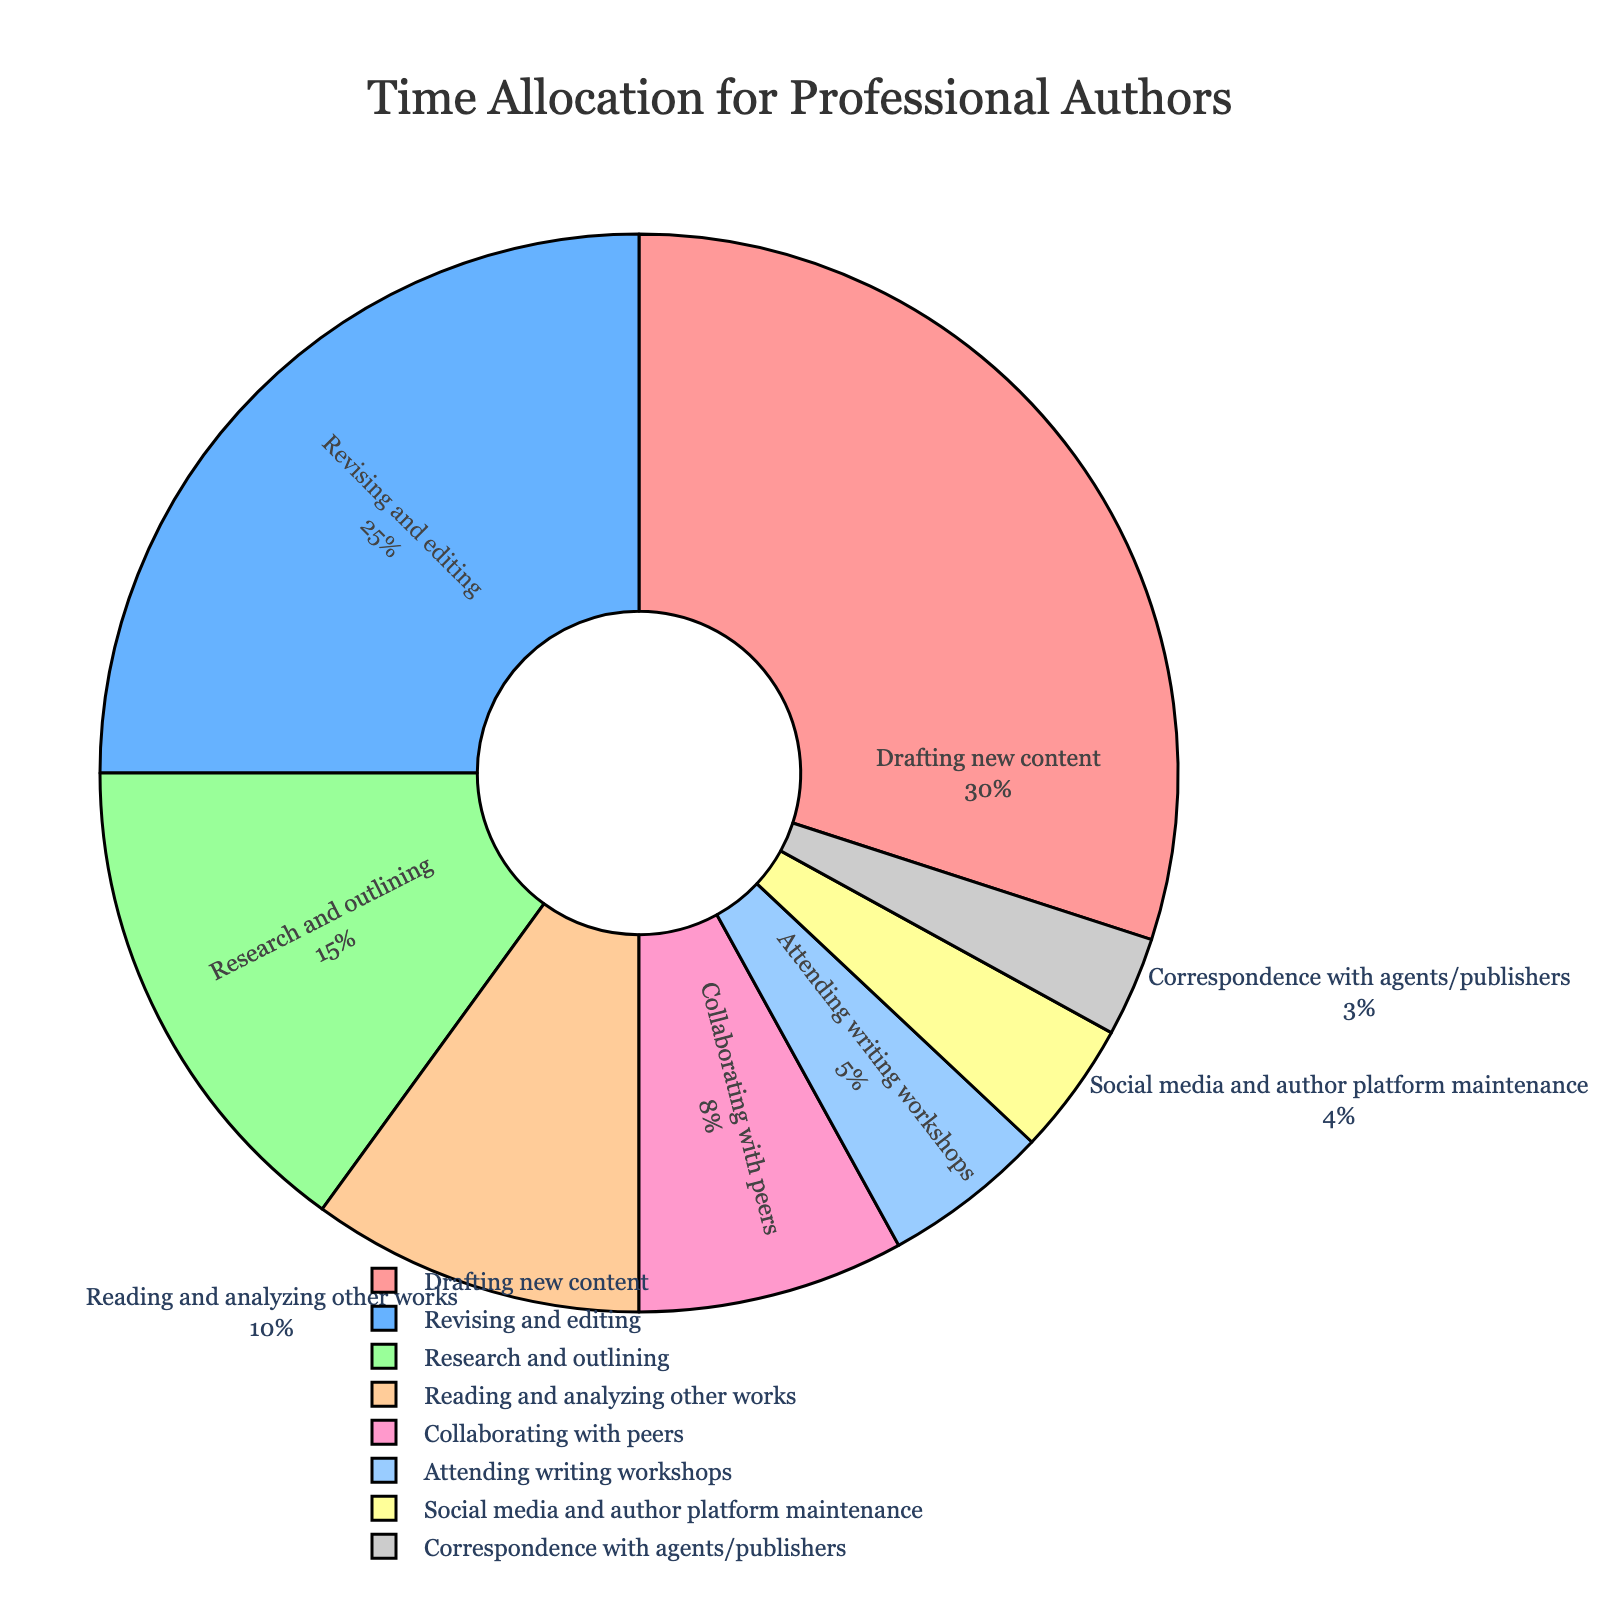Which activity do professional authors spend the most time on? The chart shows multiple activities with different percentages. By observing the chart, the activity with the largest slice is easily identified as the one with 30%.
Answer: Drafting new content What is the combined percentage of time spent on research and outlining and reading and analyzing other works? To find the combined percentage, add the percentages of time spent on research and outlining (15%) and reading and analyzing other works (10%). 15% + 10% = 25%.
Answer: 25% How much more time do professional authors spend on revising and editing compared to attending writing workshops? The time spent on revising and editing is 25% and the time spent on attending writing workshops is 5%. The difference is calculated as 25% - 5%.
Answer: 20% Which two activities combined take up the same amount of time as drafting new content? Drafting new content takes up 30%. By finding pairs of activities from the chart, we see that combining revising and editing (25%) and correspondence with agents/publishers (3%) yields 28%, moving on; research and outlining (15%) and reading and analyzing other works (10%) sum up to 25%. Finally, combining revising and editing (25%) and attending writing workshops (5%) gives 30%, which matches.
Answer: Revising and editing and attending writing workshops Which activity has the least time allocation, and what is its percentage? Observing the chart, the smallest slice represents the activity with only 3%.
Answer: Correspondence with agents/publishers, 3% How much total time is spent on activities related to writing (excluding social media and correspondence)? By excluding the percentages for social media (4%) and correspondence (3%), sum up the remaining percentages: 30% + 25% + 15% + 10% + 8% + 5% = 93%.
Answer: 93% If visualized, which segment on the pie chart would combine into a quarter if added together? A quarter of 100% is 25%. The segment corresponding to revising and editing is 25%, precisely a quarter.
Answer: Revising and editing Compare and contrast the time spent on social media and author platform maintenance with the time spent collaborating with peers. The percentage for social media and author platform maintenance is 4%, while collaborating with peers takes 8%. 8% is twice as much as 4%.
Answer: Collaborating with peers is twice as much as social media Which activities together account for more than half of the total time? Sum the percentages to see which activities together exceed 50%. Drafting new content (30%) and revising and editing (25%) add up to 55%. This is already more than half.
Answer: Drafting new content and revising/editing 